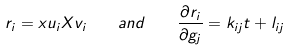<formula> <loc_0><loc_0><loc_500><loc_500>r _ { i } = x u _ { i } X v _ { i } \quad a n d \quad \frac { \partial r _ { i } } { \partial g _ { j } } = k _ { i j } t + l _ { i j }</formula> 